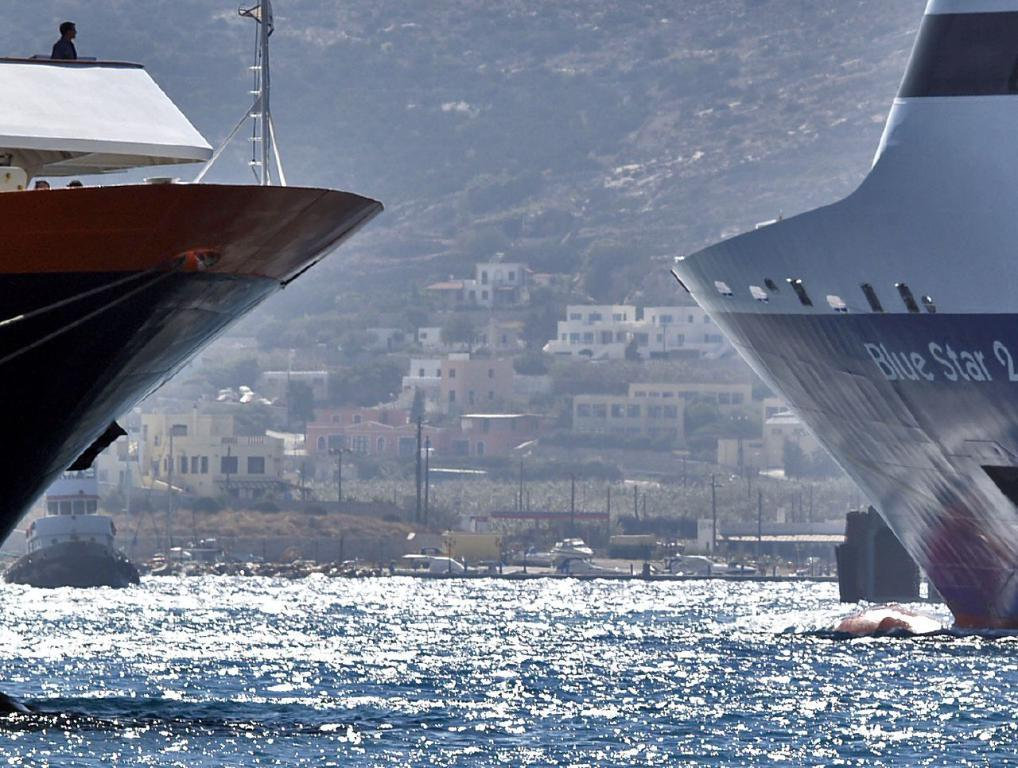Provide a one-sentence caption for the provided image. A blue & white ship on right, containing the words Blue Star, and a black, red & white ship on left and a town in background. 